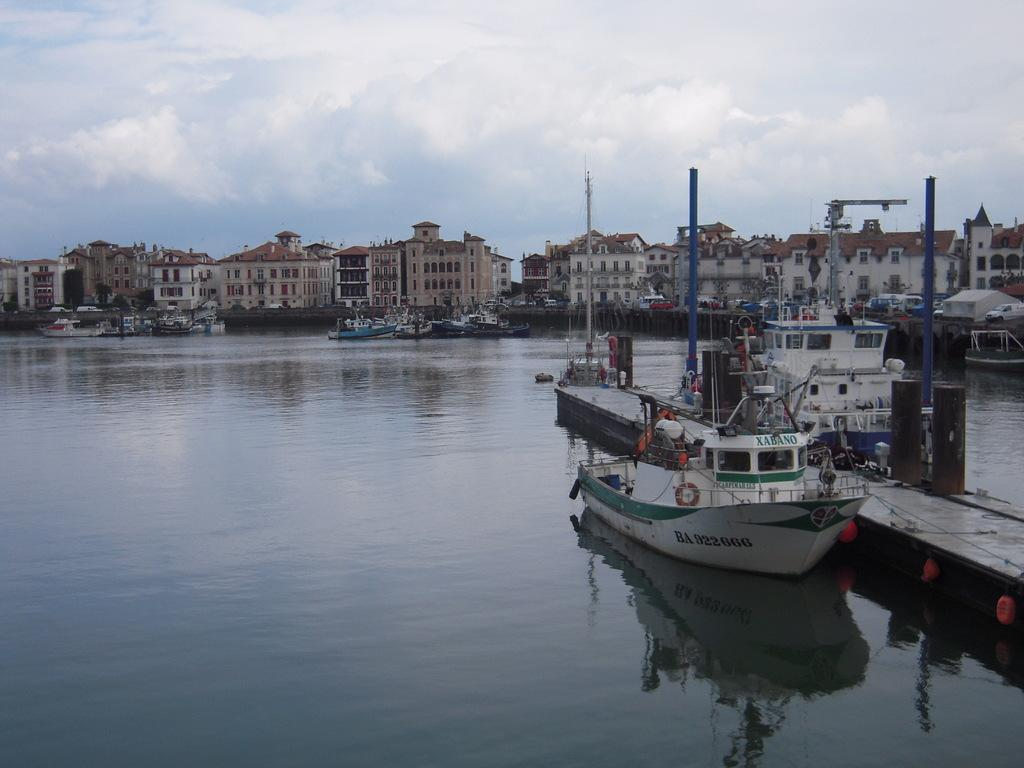Provide a one-sentence caption for the provided image. A boat named Xabano is docked in the marina on a cloudy day. 